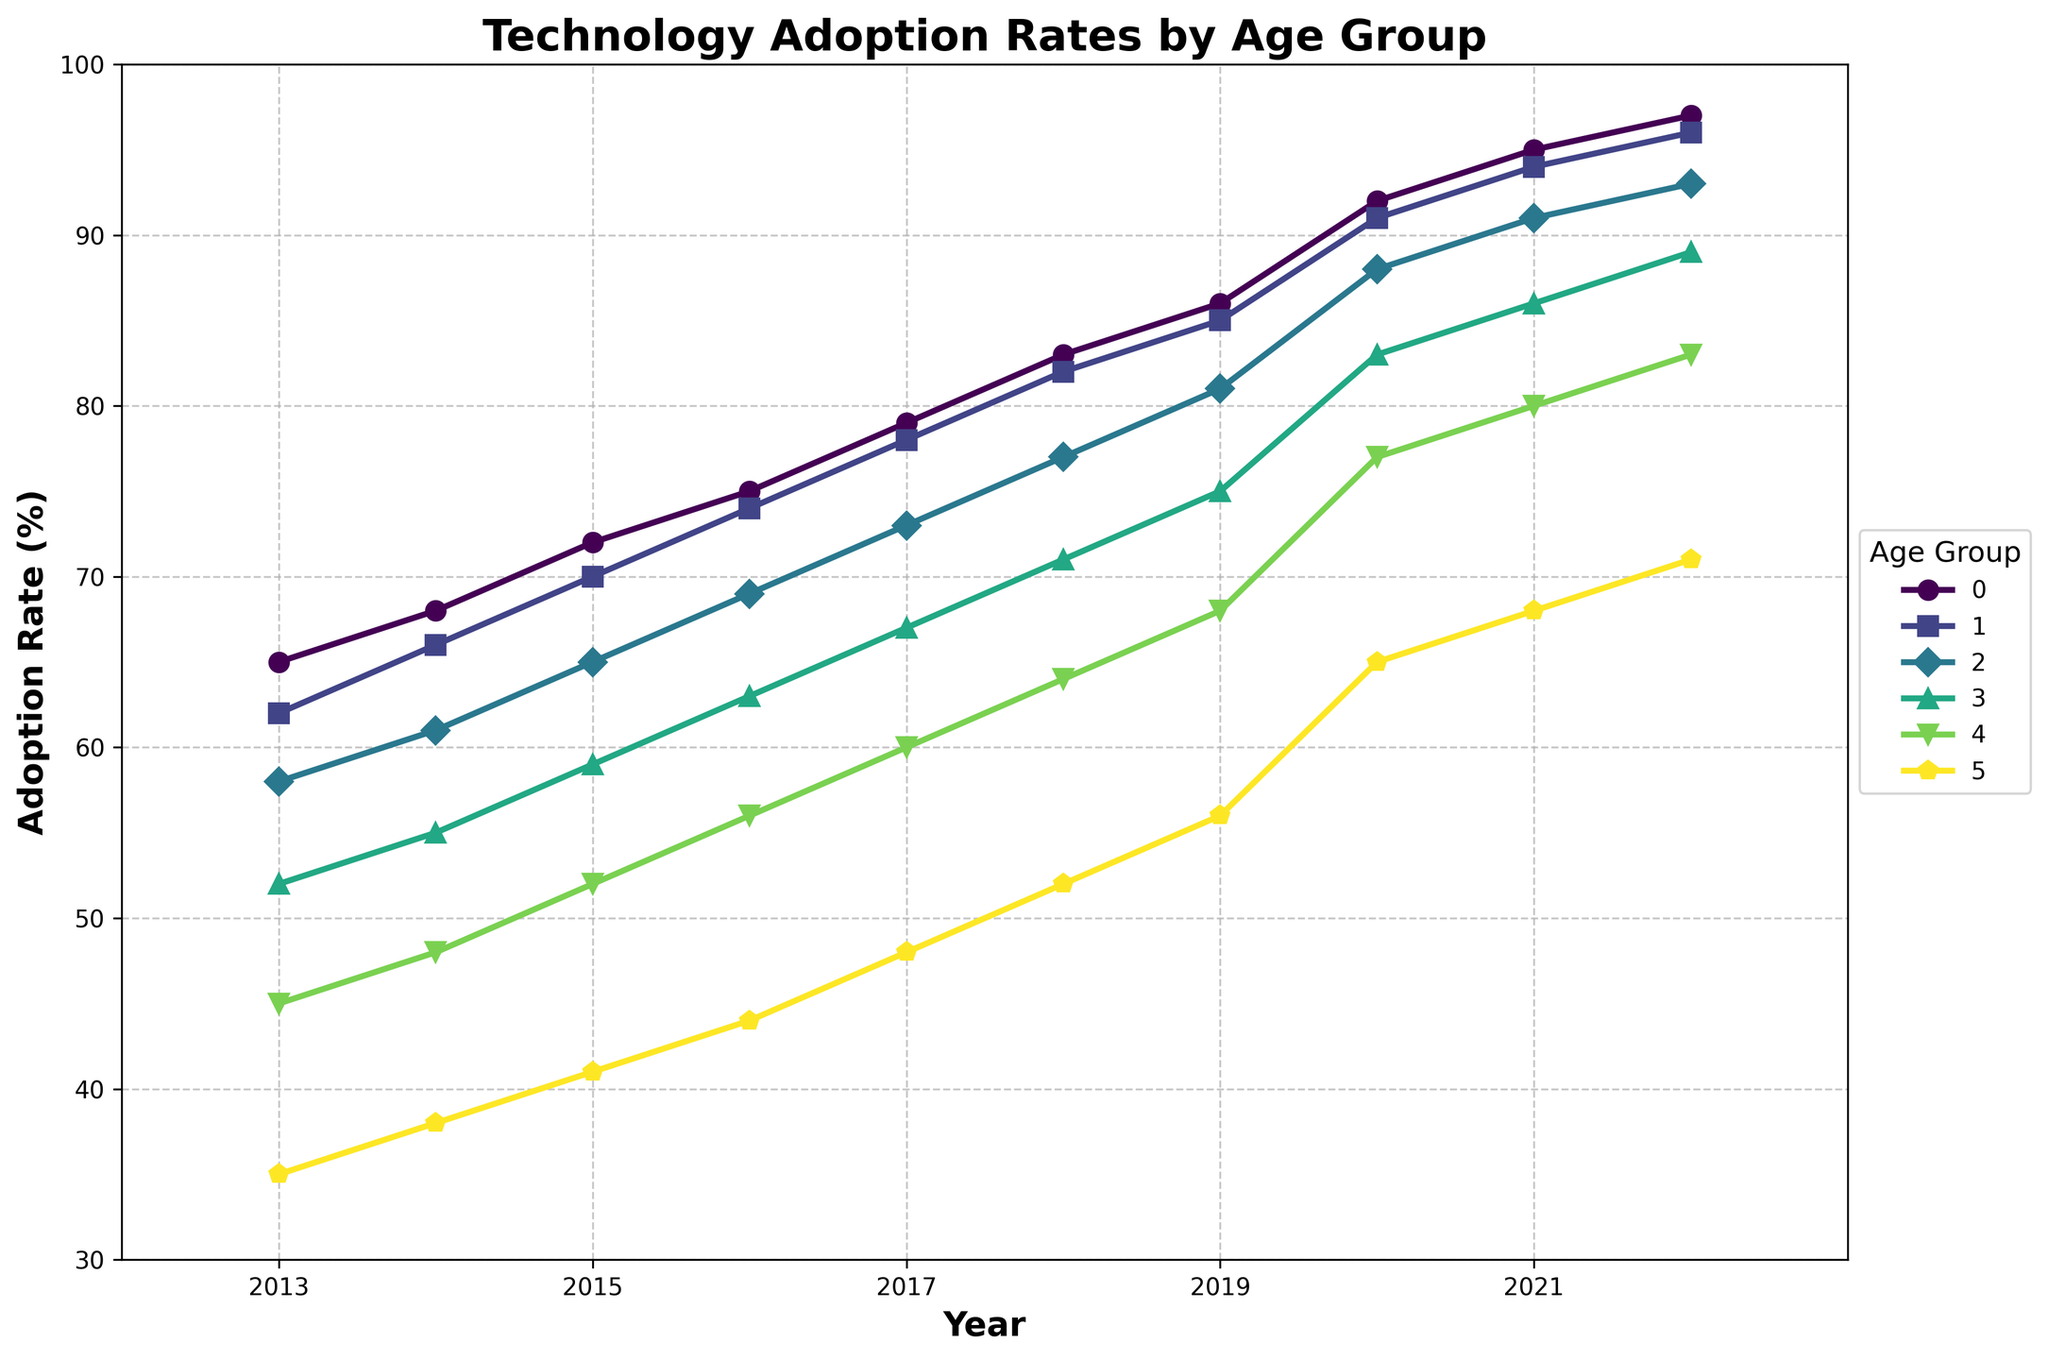What is the trend for the adoption rate of the 18-24 age group over the past decade? The adoption rate for the 18-24 age group has been increasing steadily. Starting at 65% in 2013 and reaching 97% in 2022. The trend showcases a consistent upward movement every year.
Answer: Increasing Which age group showed the highest adoption rate in 2022? From the figure, the 18-24 age group had the highest adoption rate in 2022 at 97%.
Answer: 18-24 age group How much did the adoption rate for the 55-64 age group increase from 2013 to 2022? In 2013, the adoption rate for the 55-64 age group was 45%, and in 2022, it was 83%. The increase is 83% - 45% = 38%.
Answer: 38% Which age group had the lowest adoption rate every year? The 65+ age group consistently had the lowest adoption rate each year, starting from 35% in 2013 and reaching 71% in 2022.
Answer: 65+ age group Between which consecutive years did the 45-54 age group see the highest increase in the adoption rate? Look at the increments for the 45-54 age group year to year. The highest increase happened between 2019 (75%) and 2020 (83%), with a difference of 83% - 75% = 8%.
Answer: 2019-2020 How does the adoption rate of the 35-44 age group in 2016 compare to that of the 25-34 age group in the same year? In 2016, the adoption rate for the 35-44 age group was 69%, while for the 25-34 age group, it was 74%. The 25-34 age group was higher by 5%.
Answer: The 25-34 age group was higher by 5% What is the average adoption rate for the 25-34 age group from 2013 to 2022? Sum the adoption rates for each year (62 + 66 + 70 + 74 + 78 + 82 + 85 + 91 + 94 + 96) to get 798, then divide by the number of years (10). The average is 798 / 10 = 79.8%.
Answer: 79.8% In which year did the 18-24 and 25-34 age groups have an equal adoption rate? Compare the adoption rates for the 18-24 and 25-34 age groups year by year. They never had the same adoption rate in any year from 2013 to 2022.
Answer: None Which age group had the closest adoption rates in the years 2018 and 2022? Compare the rates for all age groups between 2018 and 2022. The 18-24 age group had rates 83% in 2018 and 97% in 2022, giving a difference of 14%. The closest difference.
Answer: 18-24 age group 